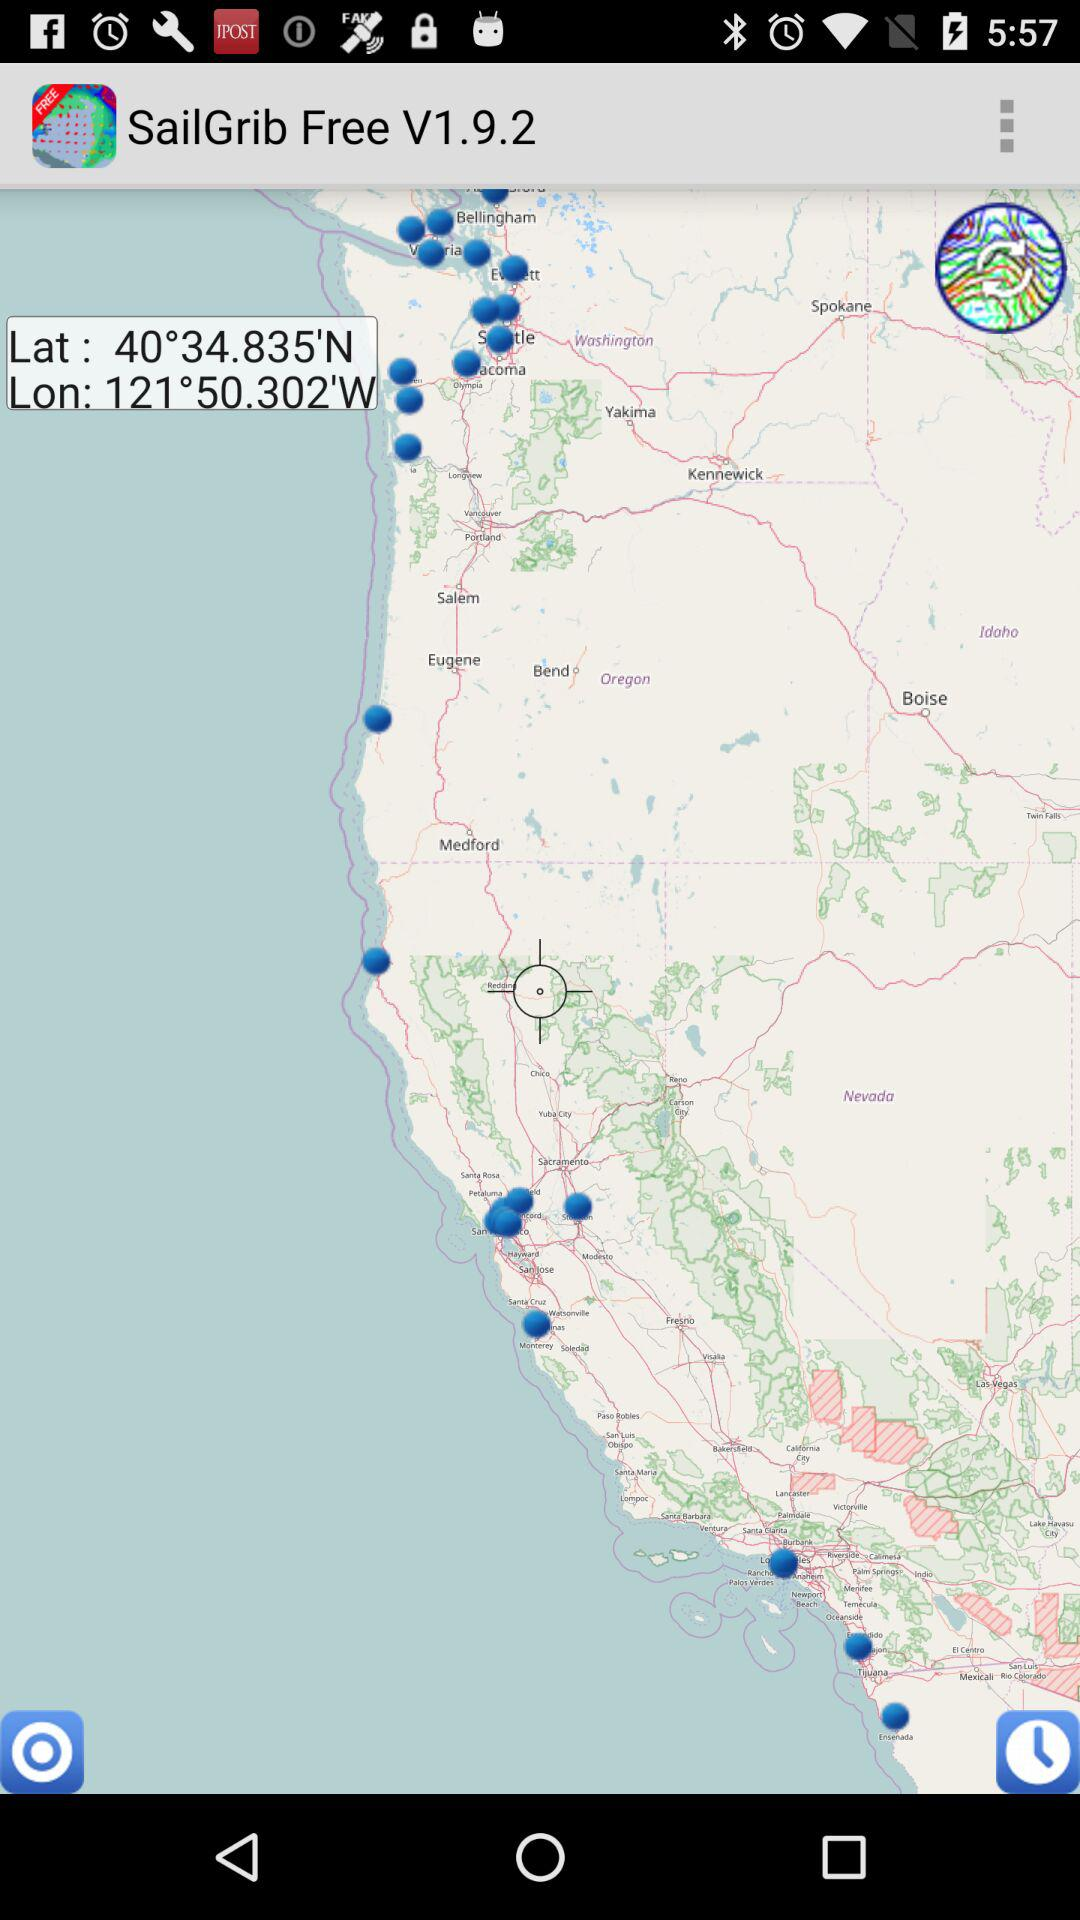What is the version? The version is V1.9.2. 